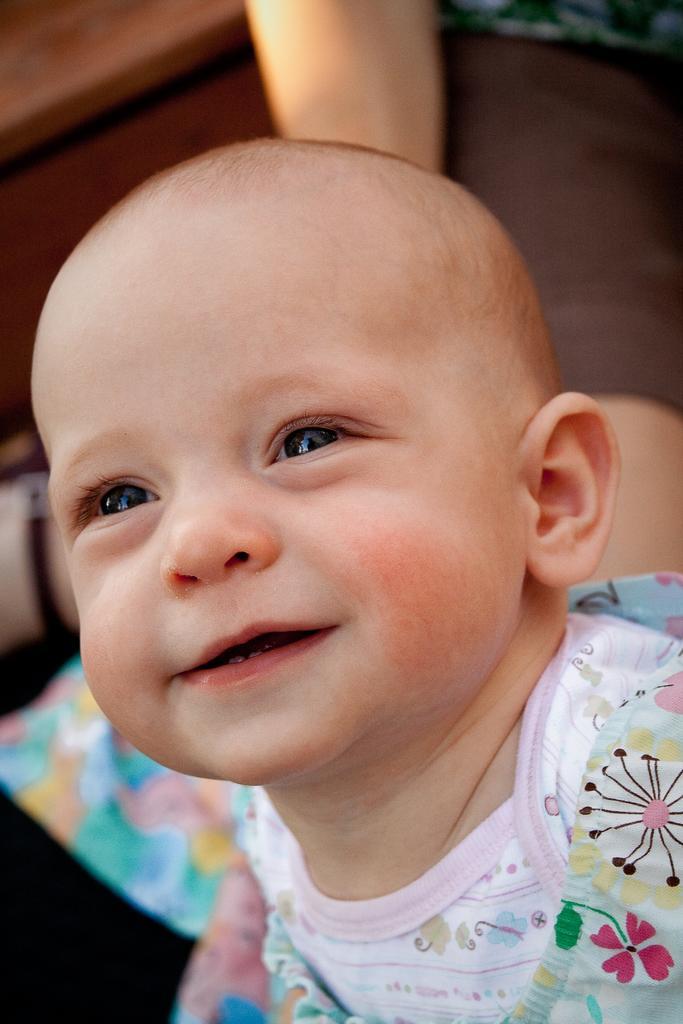Please provide a concise description of this image. In this picture there is a kid smiling. In the background of the image it is not clear. 